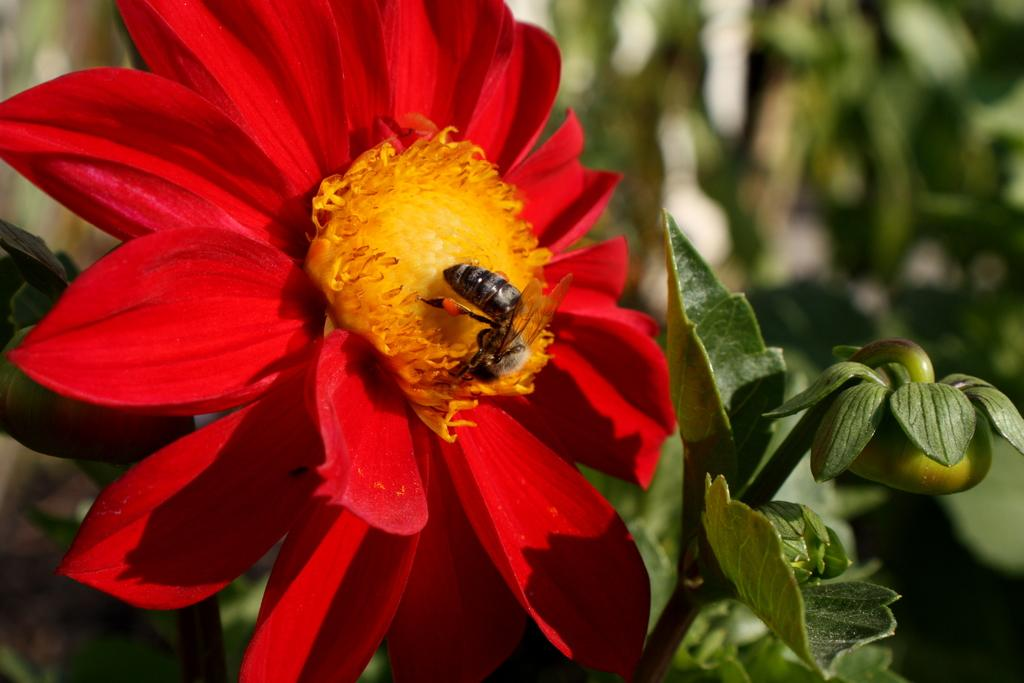What is on the flower is the bee interacting with in the image? There is a bee on a flower in the image. Can you describe the flower's appearance? The flower has a yellow part and a red color. What can be seen on the right side of the image? There is a plant with a fruit on the right side of the image. How would you describe the background of the image? The background of the image is blurred. What type of cheese is being used to water the plant in the image? There is no cheese or watering of plants depicted in the image. 